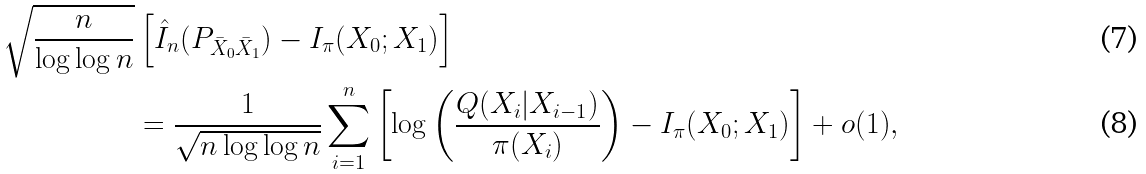<formula> <loc_0><loc_0><loc_500><loc_500>\sqrt { \frac { n } { \log \log n } } & \left [ \hat { I } _ { n } ( P _ { \bar { X } _ { 0 } \bar { X } _ { 1 } } ) - I _ { \pi } ( X _ { 0 } ; X _ { 1 } ) \right ] \\ & = \frac { 1 } { \sqrt { n \log \log n } } \sum _ { i = 1 } ^ { n } \left [ \log \left ( \frac { Q ( X _ { i } | X _ { i - 1 } ) } { \pi ( X _ { i } ) } \right ) - I _ { \pi } ( X _ { 0 } ; X _ { 1 } ) \right ] + o ( 1 ) ,</formula> 